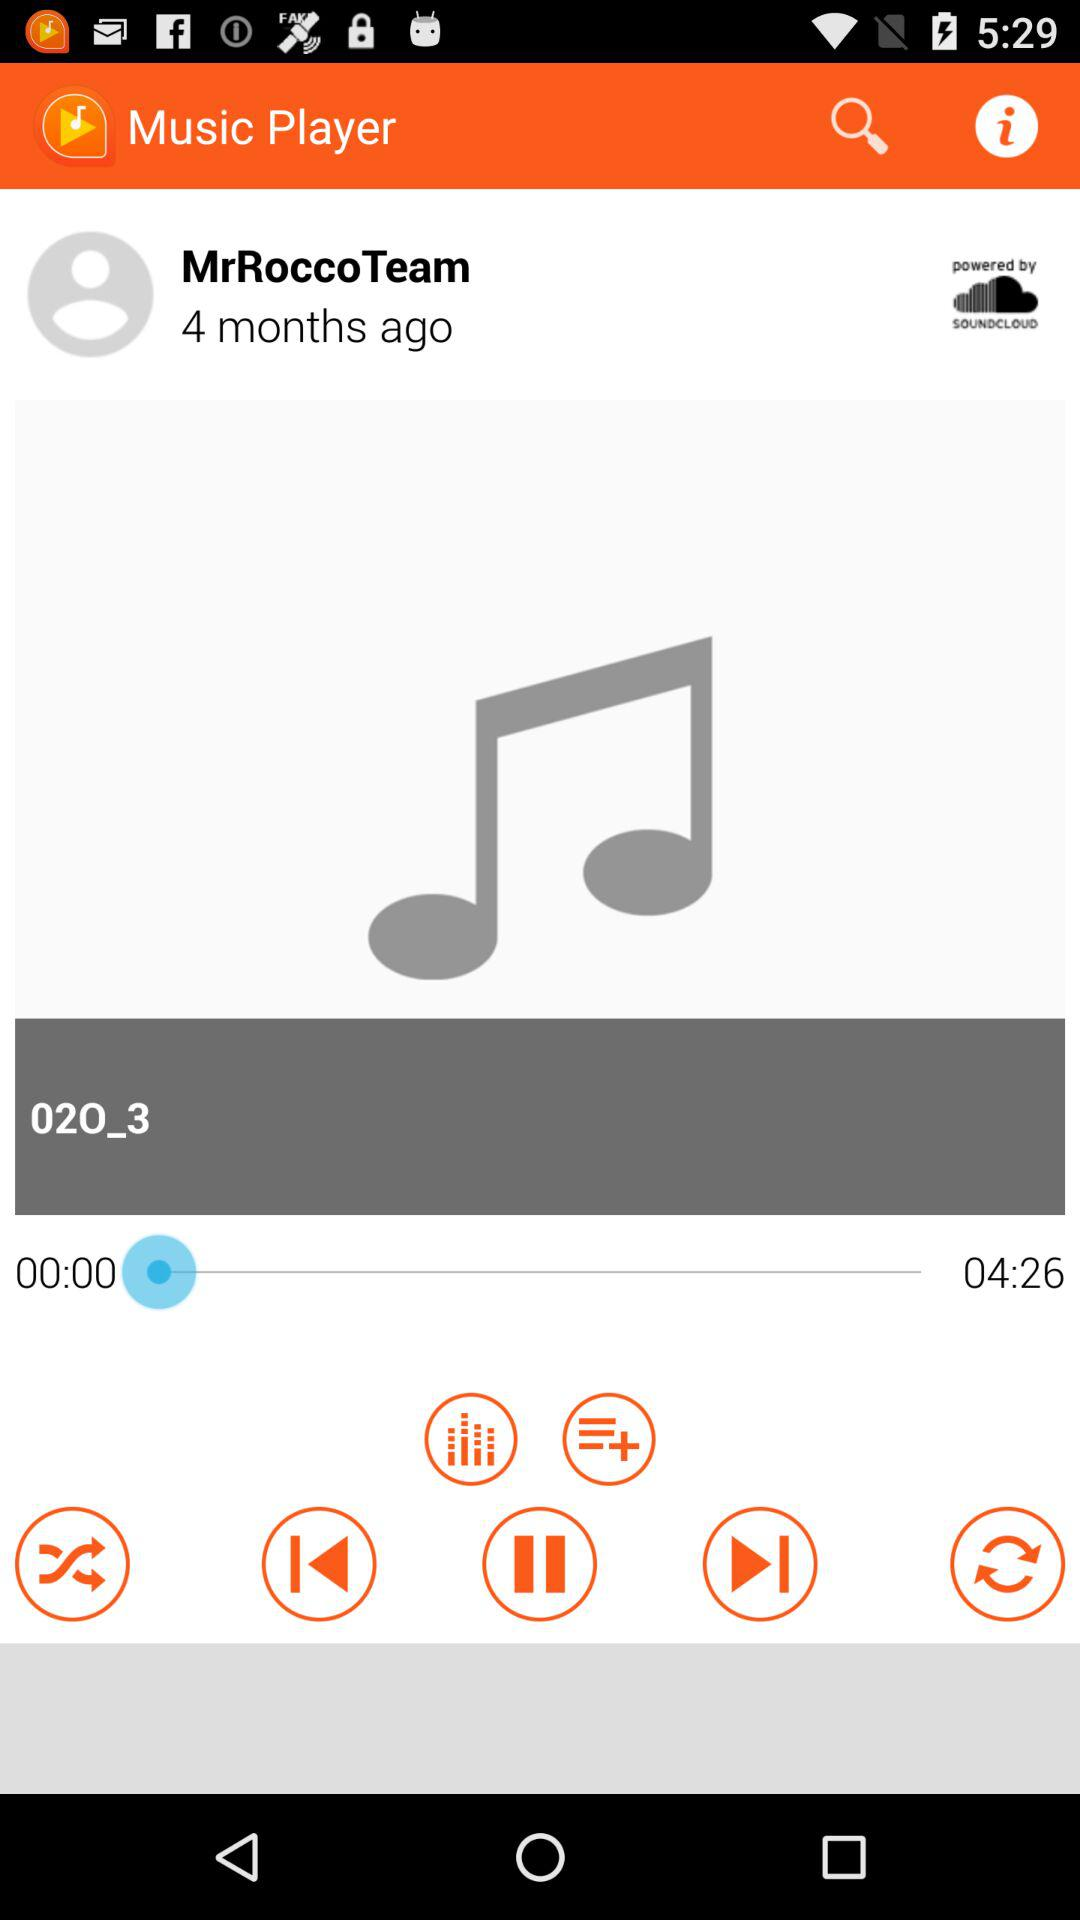Which song is currently playing? The song that is currently playing is "02O_3". 